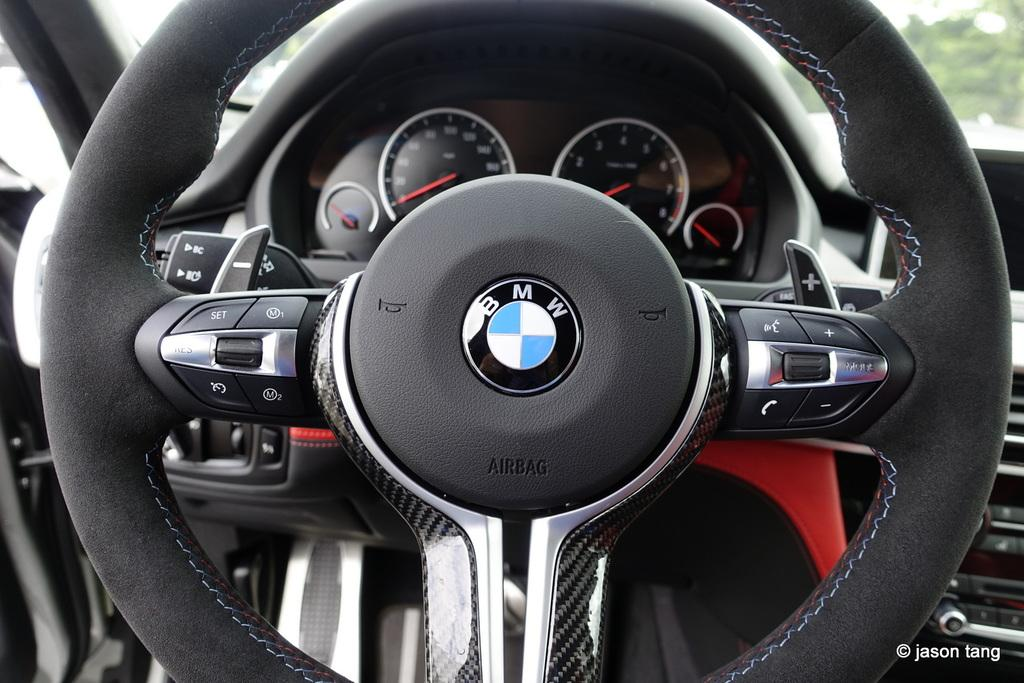What is the color of the steering wheel in the image? The steering wheel in the image is black. What instrument is present for measuring speed in the image? There is a speedometer in the image. Are there any words or text visible in the image? Yes, there is writing at a few places in the image. Is there any indication of the image's origin or ownership in the image? Yes, there is a watermark in the image. What type of vest is the writer wearing in the image? There is no writer or vest present in the image. How is the oatmeal being prepared in the image? There is no oatmeal present in the image. 